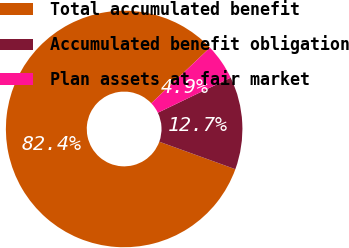Convert chart to OTSL. <chart><loc_0><loc_0><loc_500><loc_500><pie_chart><fcel>Total accumulated benefit<fcel>Accumulated benefit obligation<fcel>Plan assets at fair market<nl><fcel>82.4%<fcel>12.67%<fcel>4.92%<nl></chart> 